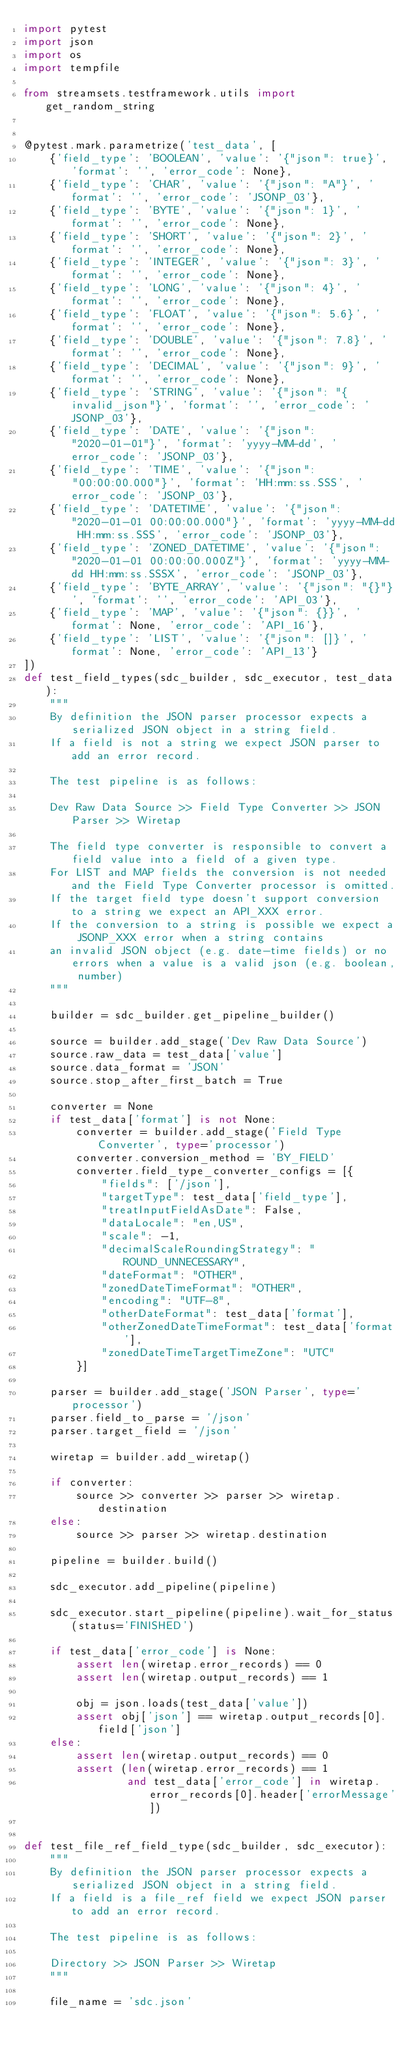Convert code to text. <code><loc_0><loc_0><loc_500><loc_500><_Python_>import pytest
import json
import os
import tempfile

from streamsets.testframework.utils import get_random_string


@pytest.mark.parametrize('test_data', [
    {'field_type': 'BOOLEAN', 'value': '{"json": true}', 'format': '', 'error_code': None},
    {'field_type': 'CHAR', 'value': '{"json": "A"}', 'format': '', 'error_code': 'JSONP_03'},
    {'field_type': 'BYTE', 'value': '{"json": 1}', 'format': '', 'error_code': None},
    {'field_type': 'SHORT', 'value': '{"json": 2}', 'format': '', 'error_code': None},
    {'field_type': 'INTEGER', 'value': '{"json": 3}', 'format': '', 'error_code': None},
    {'field_type': 'LONG', 'value': '{"json": 4}', 'format': '', 'error_code': None},
    {'field_type': 'FLOAT', 'value': '{"json": 5.6}', 'format': '', 'error_code': None},
    {'field_type': 'DOUBLE', 'value': '{"json": 7.8}', 'format': '', 'error_code': None},
    {'field_type': 'DECIMAL', 'value': '{"json": 9}', 'format': '', 'error_code': None},
    {'field_type': 'STRING', 'value': '{"json": "{invalid_json"}', 'format': '', 'error_code': 'JSONP_03'},
    {'field_type': 'DATE', 'value': '{"json": "2020-01-01"}', 'format': 'yyyy-MM-dd', 'error_code': 'JSONP_03'},
    {'field_type': 'TIME', 'value': '{"json": "00:00:00.000"}', 'format': 'HH:mm:ss.SSS', 'error_code': 'JSONP_03'},
    {'field_type': 'DATETIME', 'value': '{"json": "2020-01-01 00:00:00.000"}', 'format': 'yyyy-MM-dd HH:mm:ss.SSS', 'error_code': 'JSONP_03'},
    {'field_type': 'ZONED_DATETIME', 'value': '{"json": "2020-01-01 00:00:00.000Z"}', 'format': 'yyyy-MM-dd HH:mm:ss.SSSX', 'error_code': 'JSONP_03'},
    {'field_type': 'BYTE_ARRAY', 'value': '{"json": "{}"}', 'format': '', 'error_code': 'API_03'},
    {'field_type': 'MAP', 'value': '{"json": {}}', 'format': None, 'error_code': 'API_16'},
    {'field_type': 'LIST', 'value': '{"json": []}', 'format': None, 'error_code': 'API_13'}
])
def test_field_types(sdc_builder, sdc_executor, test_data):
    """
    By definition the JSON parser processor expects a serialized JSON object in a string field.
    If a field is not a string we expect JSON parser to add an error record.

    The test pipeline is as follows:

    Dev Raw Data Source >> Field Type Converter >> JSON Parser >> Wiretap

    The field type converter is responsible to convert a field value into a field of a given type.
    For LIST and MAP fields the conversion is not needed and the Field Type Converter processor is omitted.
    If the target field type doesn't support conversion to a string we expect an API_XXX error.
    If the conversion to a string is possible we expect a JSONP_XXX error when a string contains
    an invalid JSON object (e.g. date-time fields) or no errors when a value is a valid json (e.g. boolean, number)
    """

    builder = sdc_builder.get_pipeline_builder()

    source = builder.add_stage('Dev Raw Data Source')
    source.raw_data = test_data['value']
    source.data_format = 'JSON'
    source.stop_after_first_batch = True

    converter = None
    if test_data['format'] is not None:
        converter = builder.add_stage('Field Type Converter', type='processor')
        converter.conversion_method = 'BY_FIELD'
        converter.field_type_converter_configs = [{
            "fields": ['/json'],
            "targetType": test_data['field_type'],
            "treatInputFieldAsDate": False,
            "dataLocale": "en,US",
            "scale": -1,
            "decimalScaleRoundingStrategy": "ROUND_UNNECESSARY",
            "dateFormat": "OTHER",
            "zonedDateTimeFormat": "OTHER",
            "encoding": "UTF-8",
            "otherDateFormat": test_data['format'],
            "otherZonedDateTimeFormat": test_data['format'],
            "zonedDateTimeTargetTimeZone": "UTC"
        }]

    parser = builder.add_stage('JSON Parser', type='processor')
    parser.field_to_parse = '/json'
    parser.target_field = '/json'

    wiretap = builder.add_wiretap()

    if converter:
        source >> converter >> parser >> wiretap.destination
    else:
        source >> parser >> wiretap.destination

    pipeline = builder.build()

    sdc_executor.add_pipeline(pipeline)

    sdc_executor.start_pipeline(pipeline).wait_for_status(status='FINISHED')

    if test_data['error_code'] is None:
        assert len(wiretap.error_records) == 0
        assert len(wiretap.output_records) == 1

        obj = json.loads(test_data['value'])
        assert obj['json'] == wiretap.output_records[0].field['json']
    else:
        assert len(wiretap.output_records) == 0
        assert (len(wiretap.error_records) == 1
                and test_data['error_code'] in wiretap.error_records[0].header['errorMessage'])


def test_file_ref_field_type(sdc_builder, sdc_executor):
    """
    By definition the JSON parser processor expects a serialized JSON object in a string field.
    If a field is a file_ref field we expect JSON parser to add an error record.

    The test pipeline is as follows:

    Directory >> JSON Parser >> Wiretap
    """

    file_name = 'sdc.json'</code> 